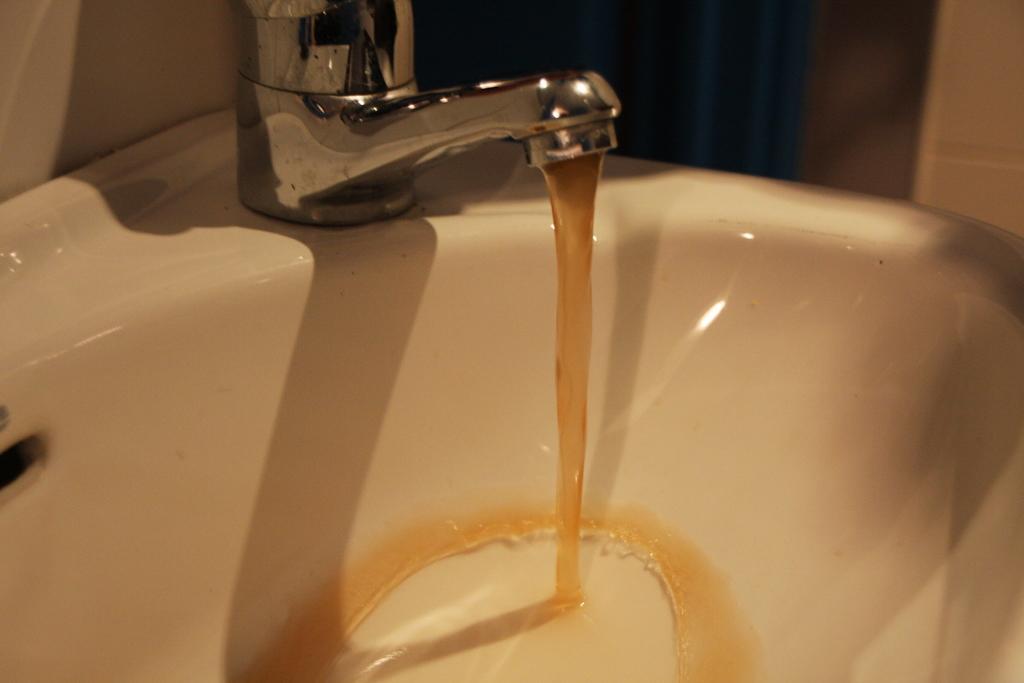Can you describe this image briefly? There is a wash basin with a tap. From the tap brown color water is coming. 